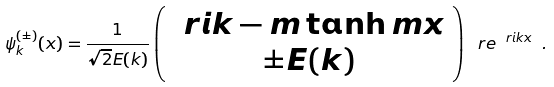Convert formula to latex. <formula><loc_0><loc_0><loc_500><loc_500>\psi _ { k } ^ { ( \pm ) } ( x ) = \frac { 1 } { \sqrt { 2 } E ( k ) } \left ( \begin{array} { c } \ r i k - m \tanh m x \\ \pm E ( k ) \end{array} \right ) \ r e ^ { \ r i k x } \ .</formula> 